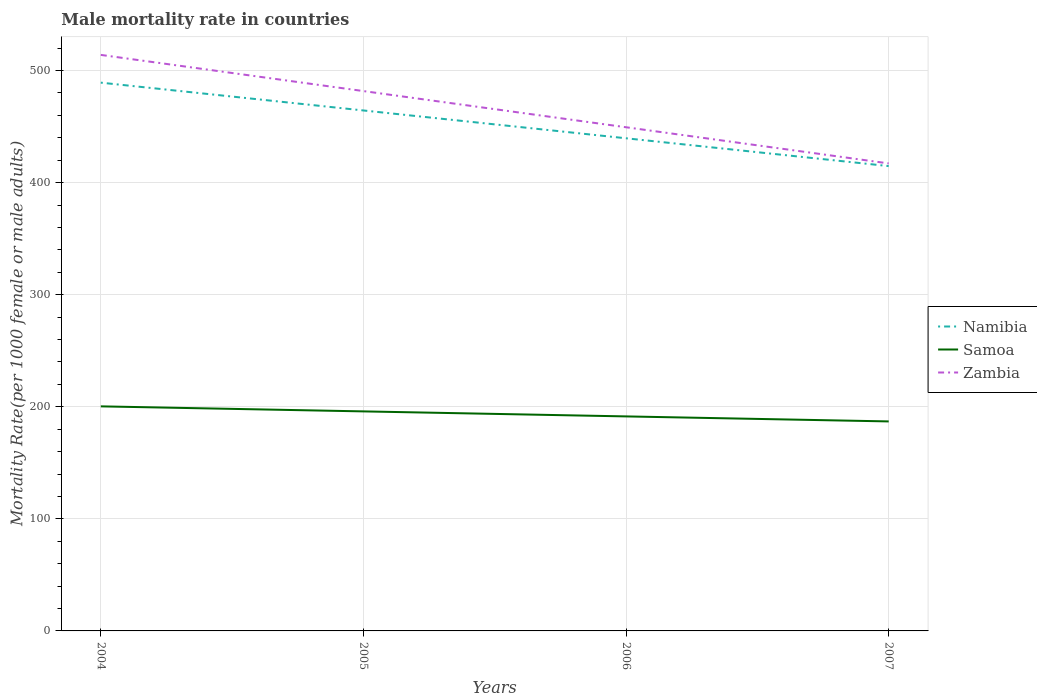How many different coloured lines are there?
Your answer should be very brief. 3. Does the line corresponding to Zambia intersect with the line corresponding to Samoa?
Provide a succinct answer. No. Across all years, what is the maximum male mortality rate in Samoa?
Make the answer very short. 186.93. In which year was the male mortality rate in Namibia maximum?
Give a very brief answer. 2007. What is the total male mortality rate in Namibia in the graph?
Your answer should be compact. 49.64. What is the difference between the highest and the second highest male mortality rate in Zambia?
Your response must be concise. 96.83. Is the male mortality rate in Namibia strictly greater than the male mortality rate in Zambia over the years?
Your response must be concise. Yes. How many years are there in the graph?
Offer a terse response. 4. What is the difference between two consecutive major ticks on the Y-axis?
Provide a succinct answer. 100. Are the values on the major ticks of Y-axis written in scientific E-notation?
Your answer should be compact. No. Does the graph contain grids?
Keep it short and to the point. Yes. Where does the legend appear in the graph?
Ensure brevity in your answer.  Center right. How are the legend labels stacked?
Make the answer very short. Vertical. What is the title of the graph?
Provide a short and direct response. Male mortality rate in countries. What is the label or title of the Y-axis?
Your answer should be compact. Mortality Rate(per 1000 female or male adults). What is the Mortality Rate(per 1000 female or male adults) of Namibia in 2004?
Offer a very short reply. 489.2. What is the Mortality Rate(per 1000 female or male adults) of Samoa in 2004?
Ensure brevity in your answer.  200.37. What is the Mortality Rate(per 1000 female or male adults) in Zambia in 2004?
Offer a very short reply. 513.96. What is the Mortality Rate(per 1000 female or male adults) in Namibia in 2005?
Your response must be concise. 464.38. What is the Mortality Rate(per 1000 female or male adults) in Samoa in 2005?
Ensure brevity in your answer.  195.88. What is the Mortality Rate(per 1000 female or male adults) in Zambia in 2005?
Offer a very short reply. 481.68. What is the Mortality Rate(per 1000 female or male adults) in Namibia in 2006?
Your answer should be compact. 439.56. What is the Mortality Rate(per 1000 female or male adults) in Samoa in 2006?
Your response must be concise. 191.41. What is the Mortality Rate(per 1000 female or male adults) in Zambia in 2006?
Make the answer very short. 449.41. What is the Mortality Rate(per 1000 female or male adults) in Namibia in 2007?
Offer a very short reply. 414.75. What is the Mortality Rate(per 1000 female or male adults) in Samoa in 2007?
Provide a short and direct response. 186.93. What is the Mortality Rate(per 1000 female or male adults) in Zambia in 2007?
Keep it short and to the point. 417.13. Across all years, what is the maximum Mortality Rate(per 1000 female or male adults) in Namibia?
Offer a terse response. 489.2. Across all years, what is the maximum Mortality Rate(per 1000 female or male adults) of Samoa?
Ensure brevity in your answer.  200.37. Across all years, what is the maximum Mortality Rate(per 1000 female or male adults) of Zambia?
Your answer should be compact. 513.96. Across all years, what is the minimum Mortality Rate(per 1000 female or male adults) in Namibia?
Your response must be concise. 414.75. Across all years, what is the minimum Mortality Rate(per 1000 female or male adults) in Samoa?
Provide a succinct answer. 186.93. Across all years, what is the minimum Mortality Rate(per 1000 female or male adults) in Zambia?
Your response must be concise. 417.13. What is the total Mortality Rate(per 1000 female or male adults) in Namibia in the graph?
Your answer should be compact. 1807.9. What is the total Mortality Rate(per 1000 female or male adults) in Samoa in the graph?
Offer a very short reply. 774.58. What is the total Mortality Rate(per 1000 female or male adults) of Zambia in the graph?
Ensure brevity in your answer.  1862.18. What is the difference between the Mortality Rate(per 1000 female or male adults) of Namibia in 2004 and that in 2005?
Make the answer very short. 24.82. What is the difference between the Mortality Rate(per 1000 female or male adults) in Samoa in 2004 and that in 2005?
Offer a very short reply. 4.48. What is the difference between the Mortality Rate(per 1000 female or male adults) in Zambia in 2004 and that in 2005?
Your answer should be compact. 32.28. What is the difference between the Mortality Rate(per 1000 female or male adults) in Namibia in 2004 and that in 2006?
Provide a short and direct response. 49.64. What is the difference between the Mortality Rate(per 1000 female or male adults) of Samoa in 2004 and that in 2006?
Offer a terse response. 8.96. What is the difference between the Mortality Rate(per 1000 female or male adults) of Zambia in 2004 and that in 2006?
Your answer should be compact. 64.56. What is the difference between the Mortality Rate(per 1000 female or male adults) of Namibia in 2004 and that in 2007?
Provide a short and direct response. 74.45. What is the difference between the Mortality Rate(per 1000 female or male adults) of Samoa in 2004 and that in 2007?
Your answer should be compact. 13.44. What is the difference between the Mortality Rate(per 1000 female or male adults) in Zambia in 2004 and that in 2007?
Provide a succinct answer. 96.83. What is the difference between the Mortality Rate(per 1000 female or male adults) in Namibia in 2005 and that in 2006?
Offer a very short reply. 24.82. What is the difference between the Mortality Rate(per 1000 female or male adults) of Samoa in 2005 and that in 2006?
Your response must be concise. 4.48. What is the difference between the Mortality Rate(per 1000 female or male adults) in Zambia in 2005 and that in 2006?
Your response must be concise. 32.28. What is the difference between the Mortality Rate(per 1000 female or male adults) of Namibia in 2005 and that in 2007?
Your response must be concise. 49.64. What is the difference between the Mortality Rate(per 1000 female or male adults) in Samoa in 2005 and that in 2007?
Provide a succinct answer. 8.96. What is the difference between the Mortality Rate(per 1000 female or male adults) in Zambia in 2005 and that in 2007?
Provide a short and direct response. 64.56. What is the difference between the Mortality Rate(per 1000 female or male adults) of Namibia in 2006 and that in 2007?
Offer a terse response. 24.82. What is the difference between the Mortality Rate(per 1000 female or male adults) in Samoa in 2006 and that in 2007?
Keep it short and to the point. 4.48. What is the difference between the Mortality Rate(per 1000 female or male adults) of Zambia in 2006 and that in 2007?
Your answer should be compact. 32.28. What is the difference between the Mortality Rate(per 1000 female or male adults) in Namibia in 2004 and the Mortality Rate(per 1000 female or male adults) in Samoa in 2005?
Make the answer very short. 293.32. What is the difference between the Mortality Rate(per 1000 female or male adults) in Namibia in 2004 and the Mortality Rate(per 1000 female or male adults) in Zambia in 2005?
Provide a succinct answer. 7.52. What is the difference between the Mortality Rate(per 1000 female or male adults) of Samoa in 2004 and the Mortality Rate(per 1000 female or male adults) of Zambia in 2005?
Make the answer very short. -281.32. What is the difference between the Mortality Rate(per 1000 female or male adults) in Namibia in 2004 and the Mortality Rate(per 1000 female or male adults) in Samoa in 2006?
Provide a succinct answer. 297.8. What is the difference between the Mortality Rate(per 1000 female or male adults) in Namibia in 2004 and the Mortality Rate(per 1000 female or male adults) in Zambia in 2006?
Make the answer very short. 39.8. What is the difference between the Mortality Rate(per 1000 female or male adults) in Samoa in 2004 and the Mortality Rate(per 1000 female or male adults) in Zambia in 2006?
Ensure brevity in your answer.  -249.04. What is the difference between the Mortality Rate(per 1000 female or male adults) in Namibia in 2004 and the Mortality Rate(per 1000 female or male adults) in Samoa in 2007?
Provide a succinct answer. 302.28. What is the difference between the Mortality Rate(per 1000 female or male adults) in Namibia in 2004 and the Mortality Rate(per 1000 female or male adults) in Zambia in 2007?
Make the answer very short. 72.07. What is the difference between the Mortality Rate(per 1000 female or male adults) in Samoa in 2004 and the Mortality Rate(per 1000 female or male adults) in Zambia in 2007?
Keep it short and to the point. -216.76. What is the difference between the Mortality Rate(per 1000 female or male adults) of Namibia in 2005 and the Mortality Rate(per 1000 female or male adults) of Samoa in 2006?
Your response must be concise. 272.98. What is the difference between the Mortality Rate(per 1000 female or male adults) of Namibia in 2005 and the Mortality Rate(per 1000 female or male adults) of Zambia in 2006?
Give a very brief answer. 14.98. What is the difference between the Mortality Rate(per 1000 female or male adults) in Samoa in 2005 and the Mortality Rate(per 1000 female or male adults) in Zambia in 2006?
Your response must be concise. -253.52. What is the difference between the Mortality Rate(per 1000 female or male adults) of Namibia in 2005 and the Mortality Rate(per 1000 female or male adults) of Samoa in 2007?
Your answer should be compact. 277.46. What is the difference between the Mortality Rate(per 1000 female or male adults) in Namibia in 2005 and the Mortality Rate(per 1000 female or male adults) in Zambia in 2007?
Make the answer very short. 47.26. What is the difference between the Mortality Rate(per 1000 female or male adults) of Samoa in 2005 and the Mortality Rate(per 1000 female or male adults) of Zambia in 2007?
Offer a very short reply. -221.24. What is the difference between the Mortality Rate(per 1000 female or male adults) of Namibia in 2006 and the Mortality Rate(per 1000 female or male adults) of Samoa in 2007?
Your response must be concise. 252.64. What is the difference between the Mortality Rate(per 1000 female or male adults) in Namibia in 2006 and the Mortality Rate(per 1000 female or male adults) in Zambia in 2007?
Provide a succinct answer. 22.44. What is the difference between the Mortality Rate(per 1000 female or male adults) of Samoa in 2006 and the Mortality Rate(per 1000 female or male adults) of Zambia in 2007?
Make the answer very short. -225.72. What is the average Mortality Rate(per 1000 female or male adults) of Namibia per year?
Your response must be concise. 451.97. What is the average Mortality Rate(per 1000 female or male adults) in Samoa per year?
Ensure brevity in your answer.  193.65. What is the average Mortality Rate(per 1000 female or male adults) of Zambia per year?
Your response must be concise. 465.55. In the year 2004, what is the difference between the Mortality Rate(per 1000 female or male adults) of Namibia and Mortality Rate(per 1000 female or male adults) of Samoa?
Your answer should be compact. 288.84. In the year 2004, what is the difference between the Mortality Rate(per 1000 female or male adults) in Namibia and Mortality Rate(per 1000 female or male adults) in Zambia?
Offer a very short reply. -24.76. In the year 2004, what is the difference between the Mortality Rate(per 1000 female or male adults) of Samoa and Mortality Rate(per 1000 female or male adults) of Zambia?
Offer a terse response. -313.6. In the year 2005, what is the difference between the Mortality Rate(per 1000 female or male adults) in Namibia and Mortality Rate(per 1000 female or male adults) in Samoa?
Your answer should be compact. 268.5. In the year 2005, what is the difference between the Mortality Rate(per 1000 female or male adults) in Namibia and Mortality Rate(per 1000 female or male adults) in Zambia?
Your response must be concise. -17.3. In the year 2005, what is the difference between the Mortality Rate(per 1000 female or male adults) of Samoa and Mortality Rate(per 1000 female or male adults) of Zambia?
Offer a terse response. -285.8. In the year 2006, what is the difference between the Mortality Rate(per 1000 female or male adults) of Namibia and Mortality Rate(per 1000 female or male adults) of Samoa?
Offer a terse response. 248.16. In the year 2006, what is the difference between the Mortality Rate(per 1000 female or male adults) of Namibia and Mortality Rate(per 1000 female or male adults) of Zambia?
Give a very brief answer. -9.84. In the year 2006, what is the difference between the Mortality Rate(per 1000 female or male adults) of Samoa and Mortality Rate(per 1000 female or male adults) of Zambia?
Your answer should be compact. -258. In the year 2007, what is the difference between the Mortality Rate(per 1000 female or male adults) of Namibia and Mortality Rate(per 1000 female or male adults) of Samoa?
Keep it short and to the point. 227.82. In the year 2007, what is the difference between the Mortality Rate(per 1000 female or male adults) of Namibia and Mortality Rate(per 1000 female or male adults) of Zambia?
Provide a succinct answer. -2.38. In the year 2007, what is the difference between the Mortality Rate(per 1000 female or male adults) of Samoa and Mortality Rate(per 1000 female or male adults) of Zambia?
Offer a terse response. -230.2. What is the ratio of the Mortality Rate(per 1000 female or male adults) in Namibia in 2004 to that in 2005?
Keep it short and to the point. 1.05. What is the ratio of the Mortality Rate(per 1000 female or male adults) in Samoa in 2004 to that in 2005?
Give a very brief answer. 1.02. What is the ratio of the Mortality Rate(per 1000 female or male adults) in Zambia in 2004 to that in 2005?
Your response must be concise. 1.07. What is the ratio of the Mortality Rate(per 1000 female or male adults) in Namibia in 2004 to that in 2006?
Your response must be concise. 1.11. What is the ratio of the Mortality Rate(per 1000 female or male adults) of Samoa in 2004 to that in 2006?
Your response must be concise. 1.05. What is the ratio of the Mortality Rate(per 1000 female or male adults) of Zambia in 2004 to that in 2006?
Your answer should be compact. 1.14. What is the ratio of the Mortality Rate(per 1000 female or male adults) in Namibia in 2004 to that in 2007?
Your answer should be compact. 1.18. What is the ratio of the Mortality Rate(per 1000 female or male adults) in Samoa in 2004 to that in 2007?
Provide a short and direct response. 1.07. What is the ratio of the Mortality Rate(per 1000 female or male adults) of Zambia in 2004 to that in 2007?
Ensure brevity in your answer.  1.23. What is the ratio of the Mortality Rate(per 1000 female or male adults) in Namibia in 2005 to that in 2006?
Your response must be concise. 1.06. What is the ratio of the Mortality Rate(per 1000 female or male adults) in Samoa in 2005 to that in 2006?
Offer a terse response. 1.02. What is the ratio of the Mortality Rate(per 1000 female or male adults) in Zambia in 2005 to that in 2006?
Offer a very short reply. 1.07. What is the ratio of the Mortality Rate(per 1000 female or male adults) of Namibia in 2005 to that in 2007?
Provide a short and direct response. 1.12. What is the ratio of the Mortality Rate(per 1000 female or male adults) in Samoa in 2005 to that in 2007?
Your answer should be compact. 1.05. What is the ratio of the Mortality Rate(per 1000 female or male adults) in Zambia in 2005 to that in 2007?
Make the answer very short. 1.15. What is the ratio of the Mortality Rate(per 1000 female or male adults) of Namibia in 2006 to that in 2007?
Your answer should be very brief. 1.06. What is the ratio of the Mortality Rate(per 1000 female or male adults) of Samoa in 2006 to that in 2007?
Offer a very short reply. 1.02. What is the ratio of the Mortality Rate(per 1000 female or male adults) in Zambia in 2006 to that in 2007?
Your answer should be very brief. 1.08. What is the difference between the highest and the second highest Mortality Rate(per 1000 female or male adults) in Namibia?
Your answer should be compact. 24.82. What is the difference between the highest and the second highest Mortality Rate(per 1000 female or male adults) in Samoa?
Your answer should be very brief. 4.48. What is the difference between the highest and the second highest Mortality Rate(per 1000 female or male adults) in Zambia?
Provide a succinct answer. 32.28. What is the difference between the highest and the lowest Mortality Rate(per 1000 female or male adults) of Namibia?
Ensure brevity in your answer.  74.45. What is the difference between the highest and the lowest Mortality Rate(per 1000 female or male adults) of Samoa?
Offer a terse response. 13.44. What is the difference between the highest and the lowest Mortality Rate(per 1000 female or male adults) of Zambia?
Ensure brevity in your answer.  96.83. 